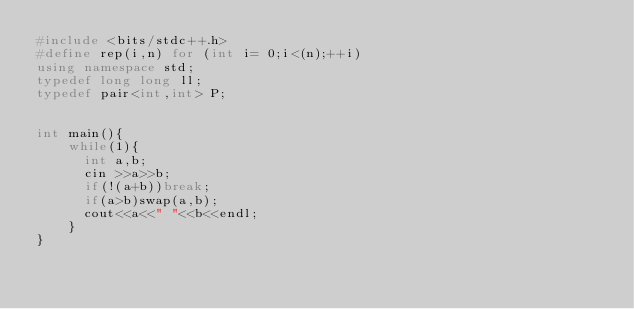<code> <loc_0><loc_0><loc_500><loc_500><_C++_>#include <bits/stdc++.h>
#define rep(i,n) for (int i= 0;i<(n);++i)
using namespace std;
typedef long long ll;
typedef pair<int,int> P;


int main(){
    while(1){
      int a,b;
      cin >>a>>b;
      if(!(a+b))break;
      if(a>b)swap(a,b);
      cout<<a<<" "<<b<<endl;
    }
}
</code> 